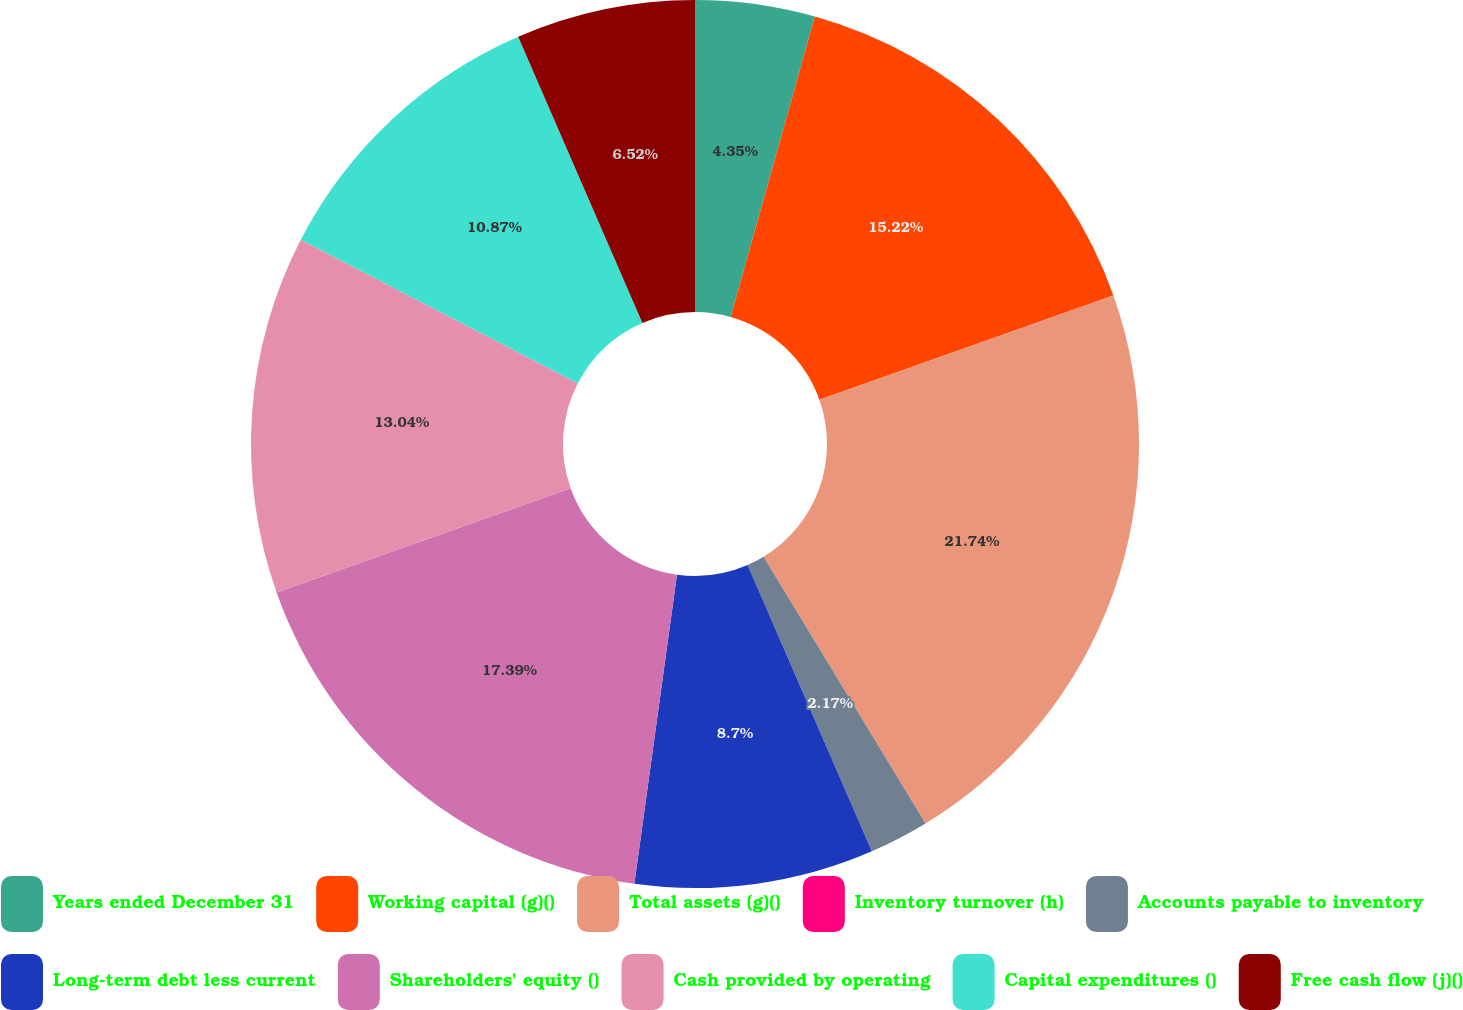Convert chart to OTSL. <chart><loc_0><loc_0><loc_500><loc_500><pie_chart><fcel>Years ended December 31<fcel>Working capital (g)()<fcel>Total assets (g)()<fcel>Inventory turnover (h)<fcel>Accounts payable to inventory<fcel>Long-term debt less current<fcel>Shareholders' equity ()<fcel>Cash provided by operating<fcel>Capital expenditures ()<fcel>Free cash flow (j)()<nl><fcel>4.35%<fcel>15.22%<fcel>21.74%<fcel>0.0%<fcel>2.17%<fcel>8.7%<fcel>17.39%<fcel>13.04%<fcel>10.87%<fcel>6.52%<nl></chart> 